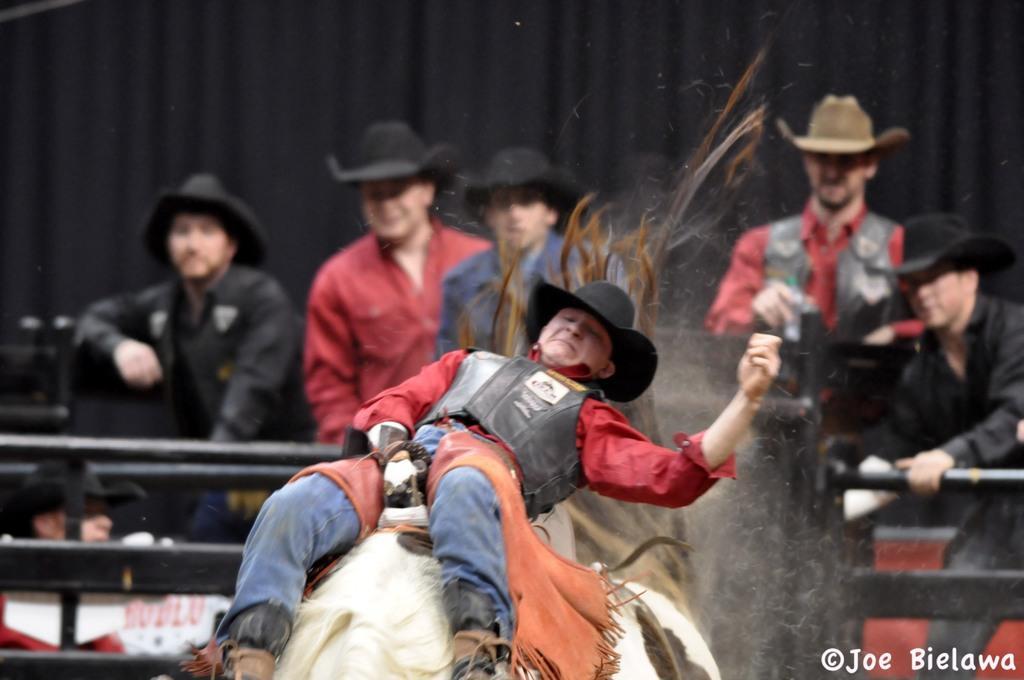Please provide a concise description of this image. in this picture one person is riding a bulakart and few persons are saying from the backside. 